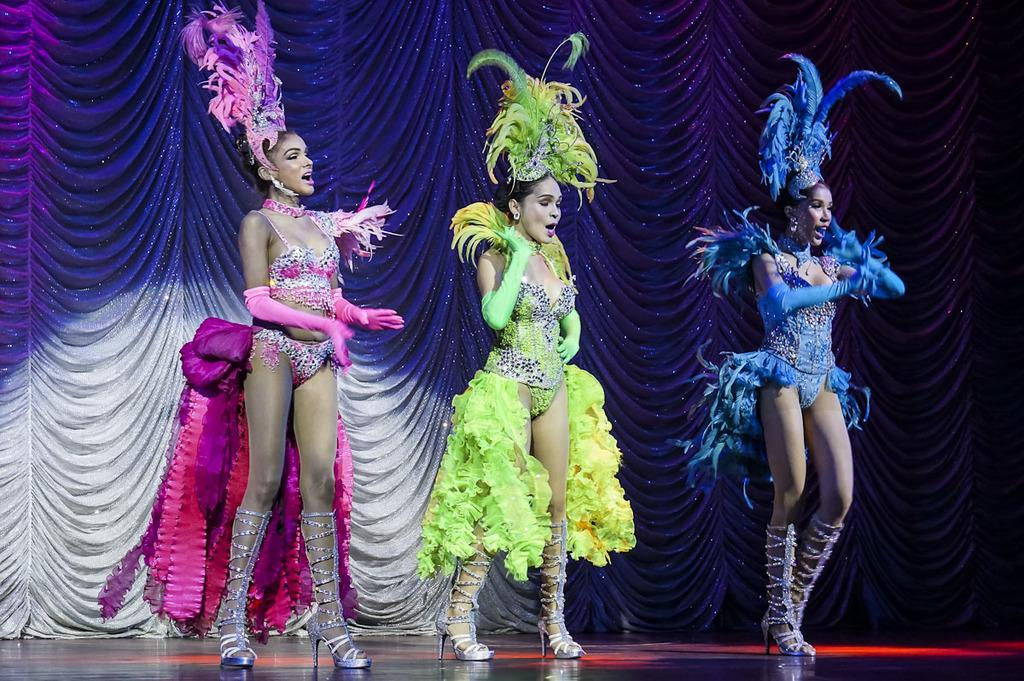How many people are in the image? There is a group of people in the image. What are the people doing in the image? The people are standing near a car. How many horses can be seen grazing on the linen in the image? There are no horses or linen present in the image; it features a group of people standing near a car. What type of crack is visible on the car's windshield in the image? There is no crack visible on the car's windshield in the image. 